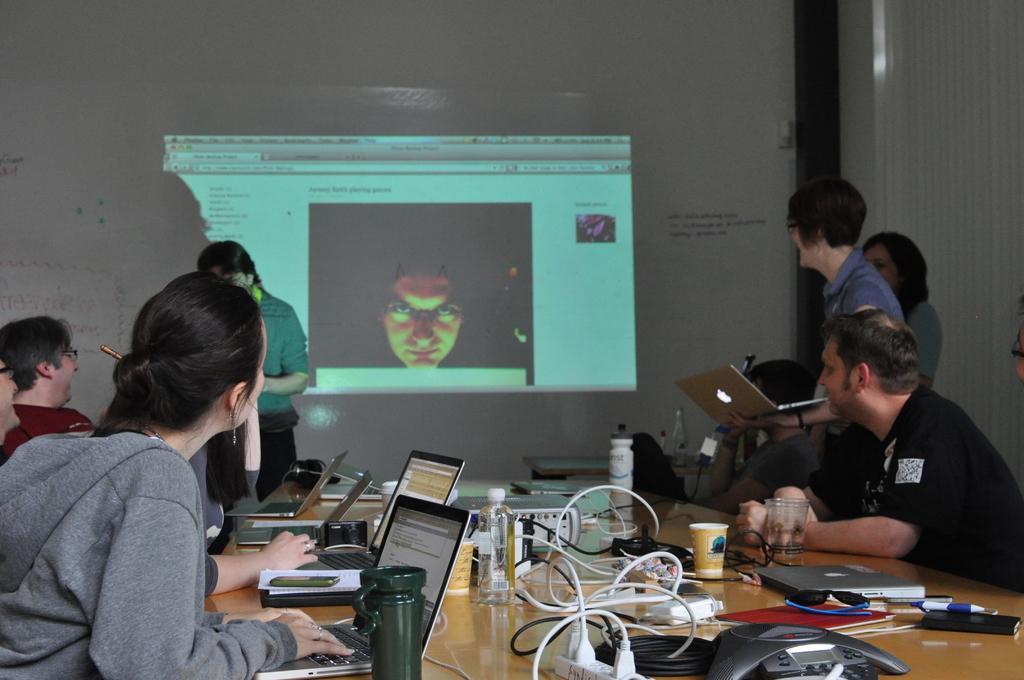In one or two sentences, can you explain what this image depicts? In this picture I can see group of people among them some are sitting and some are standing. On the table I can see laptops, wires and other objects on the table. On the right side I can see a woman is holding a laptop. In the background I can see projector screen. I can also see person's face on the projector screen. 